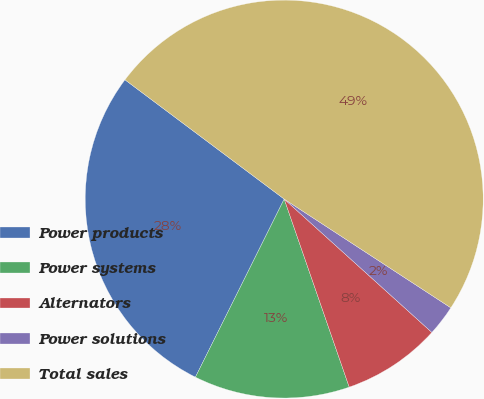Convert chart to OTSL. <chart><loc_0><loc_0><loc_500><loc_500><pie_chart><fcel>Power products<fcel>Power systems<fcel>Alternators<fcel>Power solutions<fcel>Total sales<nl><fcel>27.87%<fcel>12.66%<fcel>8.01%<fcel>2.49%<fcel>48.97%<nl></chart> 